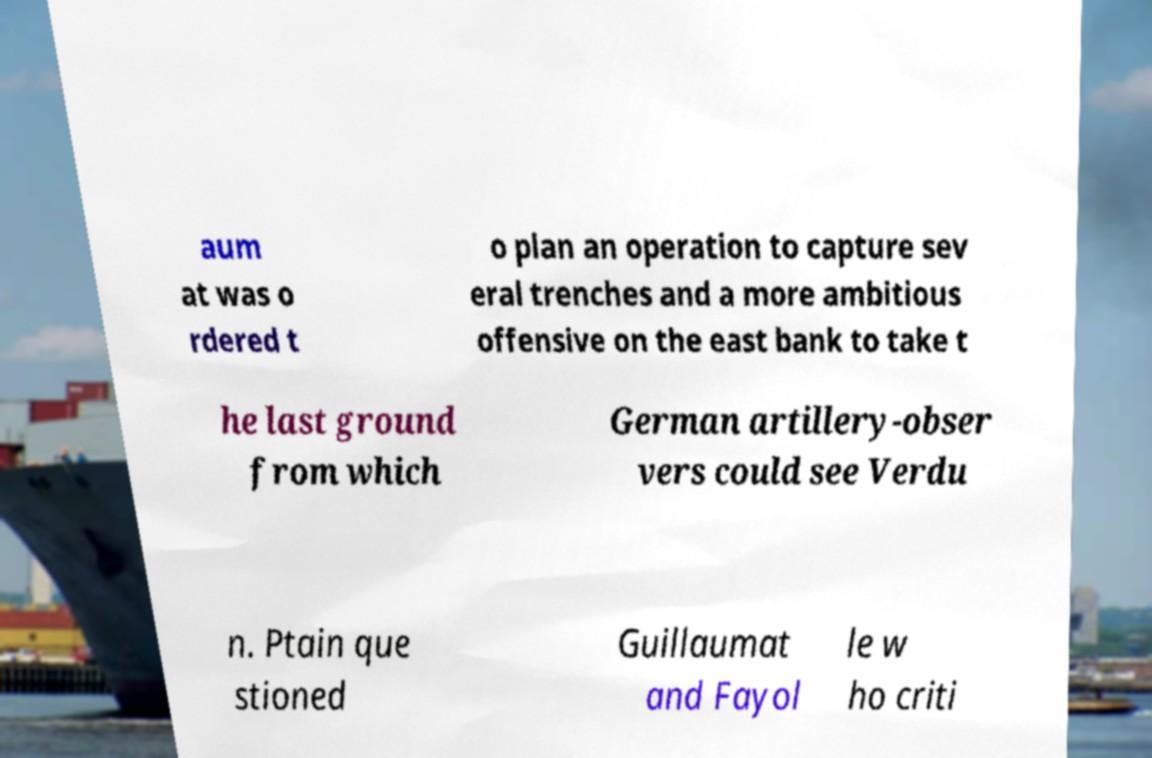Could you extract and type out the text from this image? aum at was o rdered t o plan an operation to capture sev eral trenches and a more ambitious offensive on the east bank to take t he last ground from which German artillery-obser vers could see Verdu n. Ptain que stioned Guillaumat and Fayol le w ho criti 